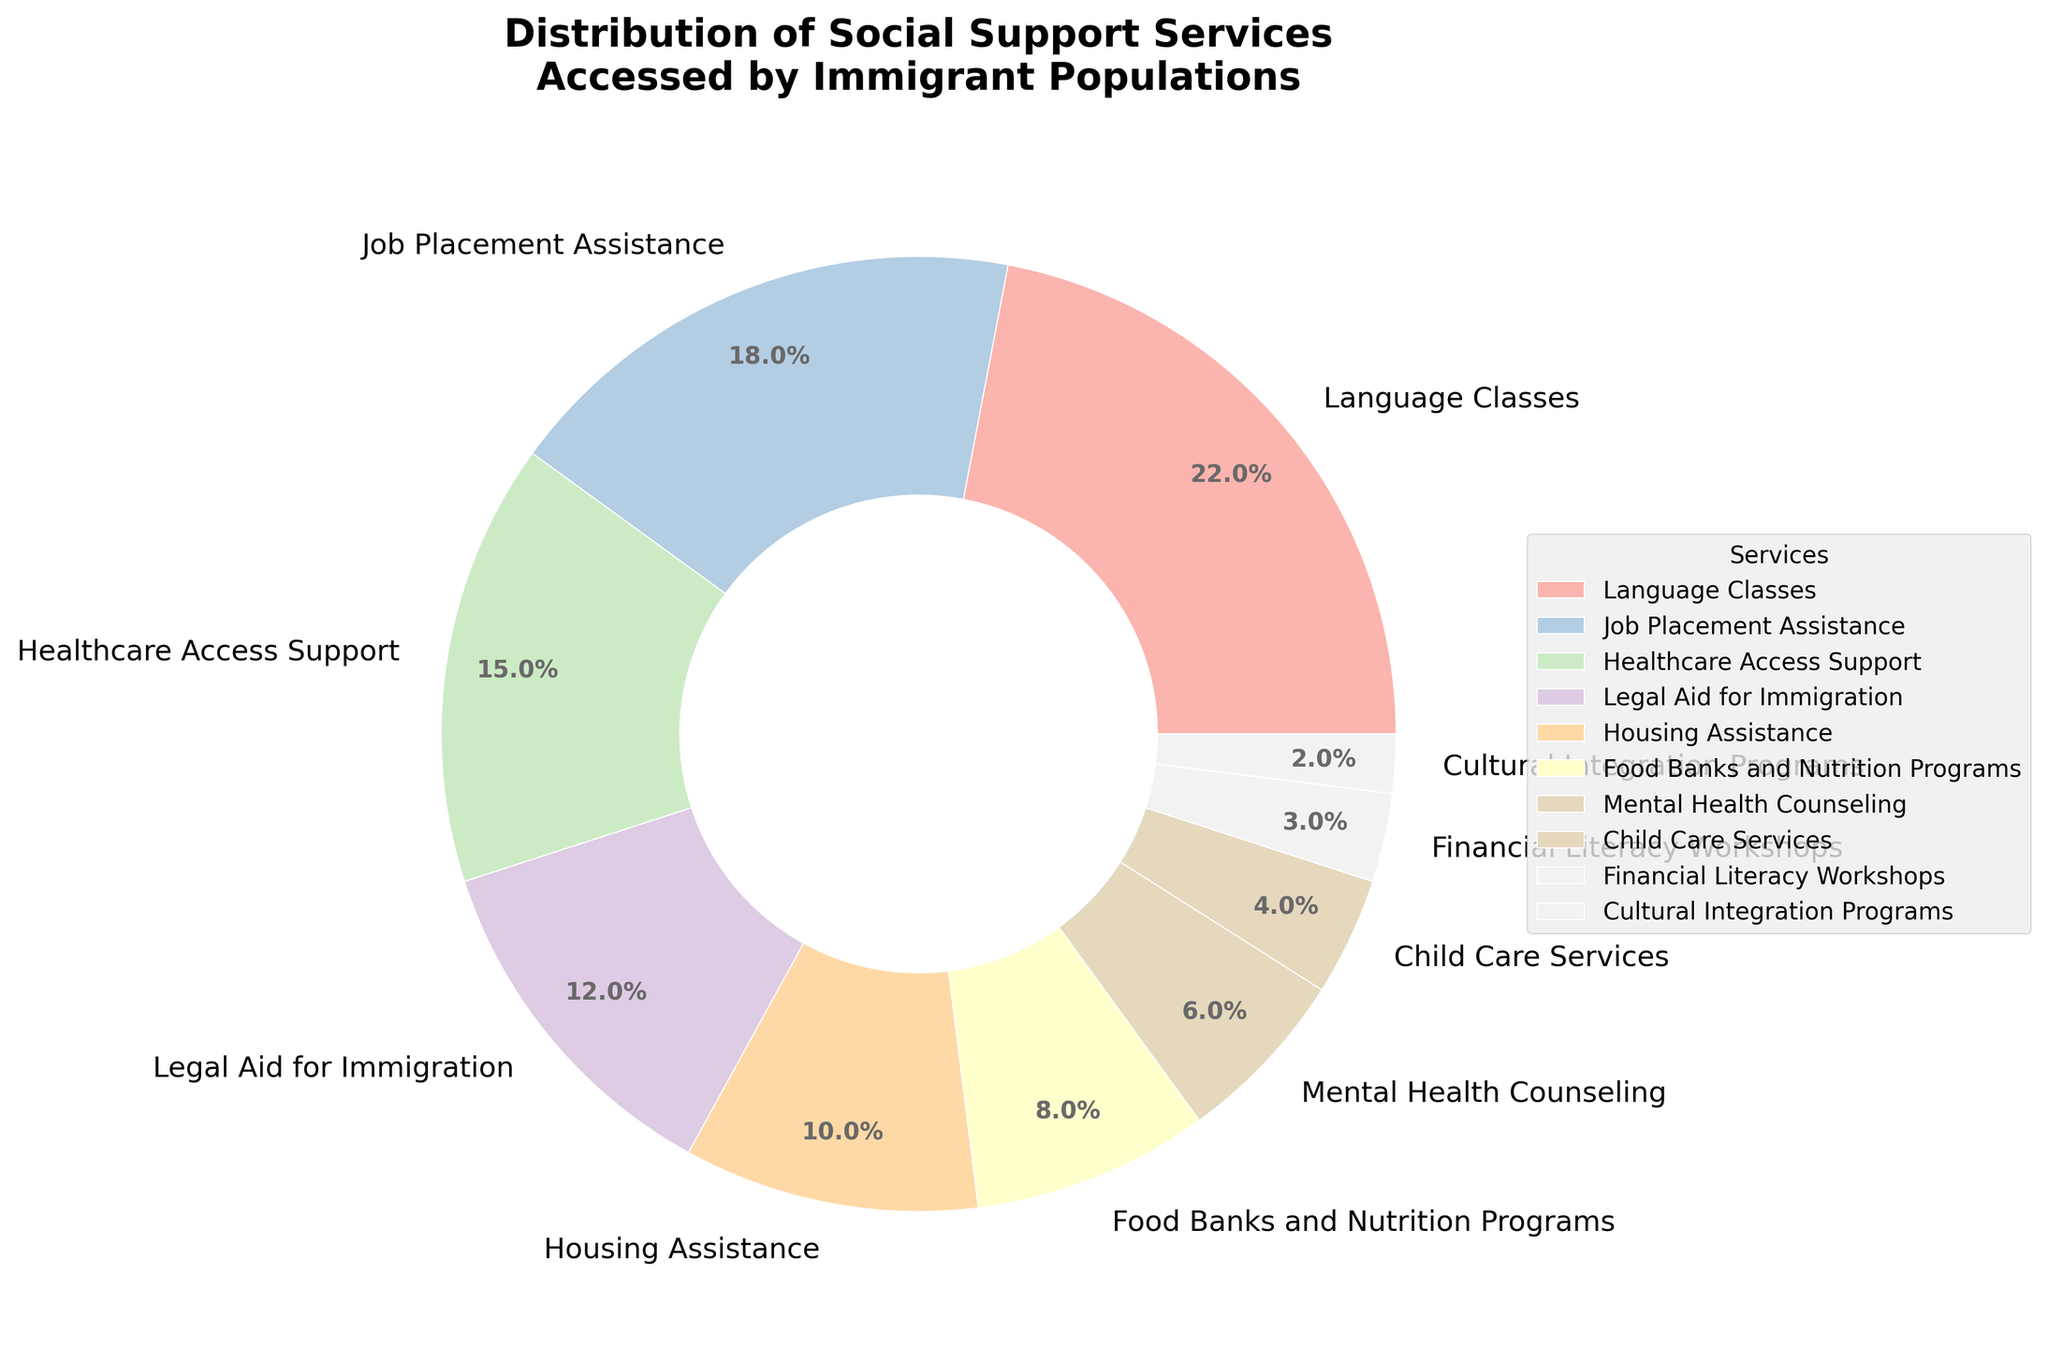What percentage of immigrants accessed Language Classes? The slice labeled "Language Classes" in the pie chart shows the percentage directly.
Answer: 22% Which service has the smallest portion of the pie chart? Look for the smallest slice in the pie chart.  It is labeled as "Cultural Integration Programs"
Answer: Cultural Integration Programs What is the combined percentage of immigrants accessing Healthcare Access Support and Job Placement Assistance? Add the percentages for Healthcare Access Support (15%) and Job Placement Assistance (18%).
Answer: 33% Is Housing Assistance accessed by a greater percentage of immigrants compared to Legal Aid for Immigration? Compare the percentages: Housing Assistance (10%) and Legal Aid for Immigration (12%).
Answer: No How much more is the percentage of immigrants accessing Language Classes compared to Mental Health Counseling? Subtract the percentage for Mental Health Counseling (6%) from Language Classes (22%).
Answer: 16% What is the difference in percentage between the highest and lowest accessed services? Subtract the smallest percentage (Cultural Integration Programs, 2%) from the largest percentage (Language Classes, 22%).
Answer: 20% What services combined make up 50% of the immigrant access? Identify services and add their percentages until the sum reaches 50%: Language Classes (22%), Job Placement Assistance (18%), and Healthcare Access Support (15%). The sum 22% + 18% + 15% = 55%, which includes 50%.
Answer: Language Classes, Job Placement Assistance, Healthcare Access Support How many services account for less than 10% of immigrants accessing each? Count the slices with a percentage less than 10%: Food Banks and Nutrition Programs (8%), Mental Health Counseling (6%), Child Care Services (4%), Financial Literacy Workshops (3%), and Cultural Integration Programs (2%).
Answer: Five Which service has an equal or smaller share than Child Care Services? Compare services to Child Care Services (4%). Financial Literacy Workshops (3%), Cultural Integration Programs (2%) have equal or smaller shares.
Answer: Financial Literacy Workshops, Cultural Integration Programs What is the total percentage of the top three most accessed services? Add the percentages for the top three most accessed services: Language Classes (22%), Job Placement Assistance (18%), and Healthcare Access Support (15%).
Answer: 55% 